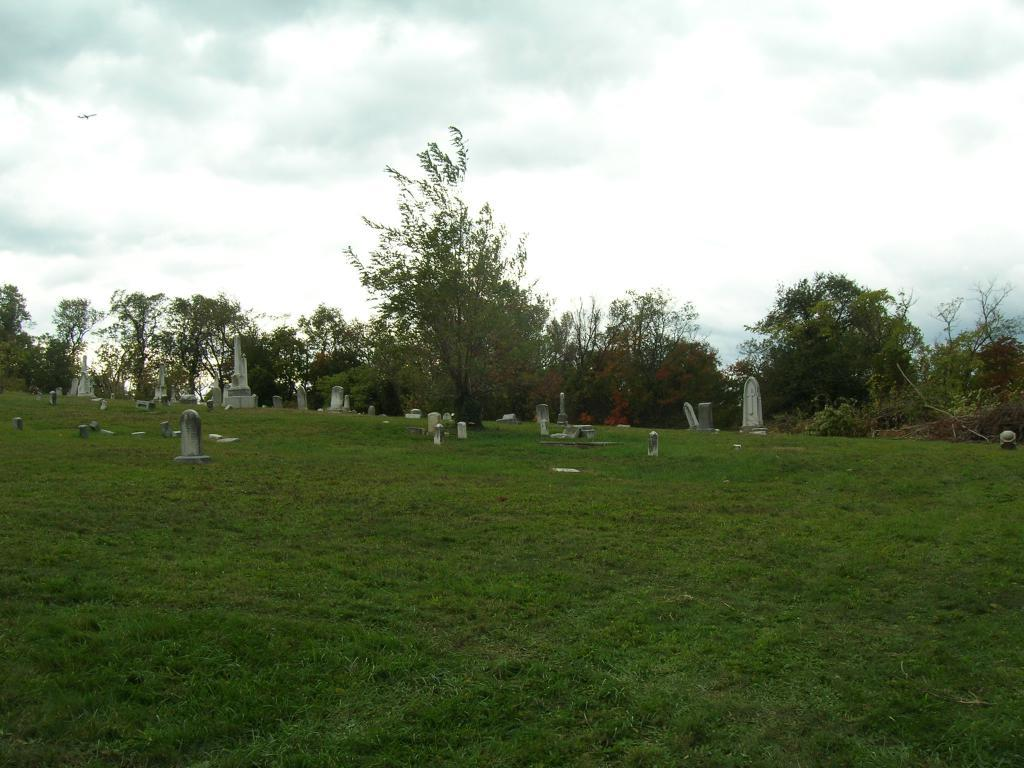What type of location is depicted in the image? The image contains a graveyard. What type of vegetation is at the bottom of the image? There is grass at the bottom of the image. What can be seen in the background of the image? There are trees and the sky visible in the background of the image. What is the condition of the sky in the image? Clouds are present in the background of the image. Can you tell me how many squares are present in the image? There are no squares present in the image; it features a graveyard with grass, trees, and a sky with clouds. Is there a man pushing a cart in the image? There is no man or cart present in the image. 